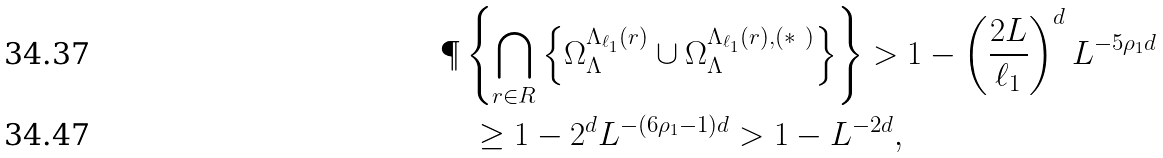<formula> <loc_0><loc_0><loc_500><loc_500>& \P \left \{ \bigcap _ { r \in R } \left \{ \Omega _ { \Lambda } ^ { \Lambda _ { \ell _ { 1 } } ( r ) } \cup \Omega _ { \Lambda } ^ { \Lambda _ { \ell _ { 1 } } ( r ) , ( * \ ) } \right \} \right \} > 1 - \left ( \frac { 2 L } { \ell _ { 1 } } \right ) ^ { d } L ^ { - 5 \rho _ { 1 } d } \\ & \quad \geq 1 - 2 ^ { d } L ^ { - ( 6 \rho _ { 1 } - 1 ) d } > 1 - L ^ { - 2 d } ,</formula> 